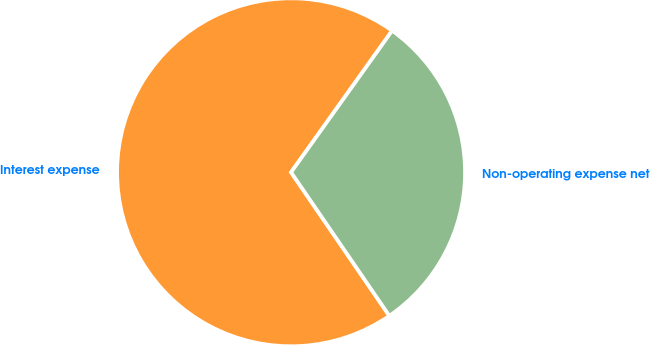<chart> <loc_0><loc_0><loc_500><loc_500><pie_chart><fcel>Interest expense<fcel>Non-operating expense net<nl><fcel>69.42%<fcel>30.58%<nl></chart> 